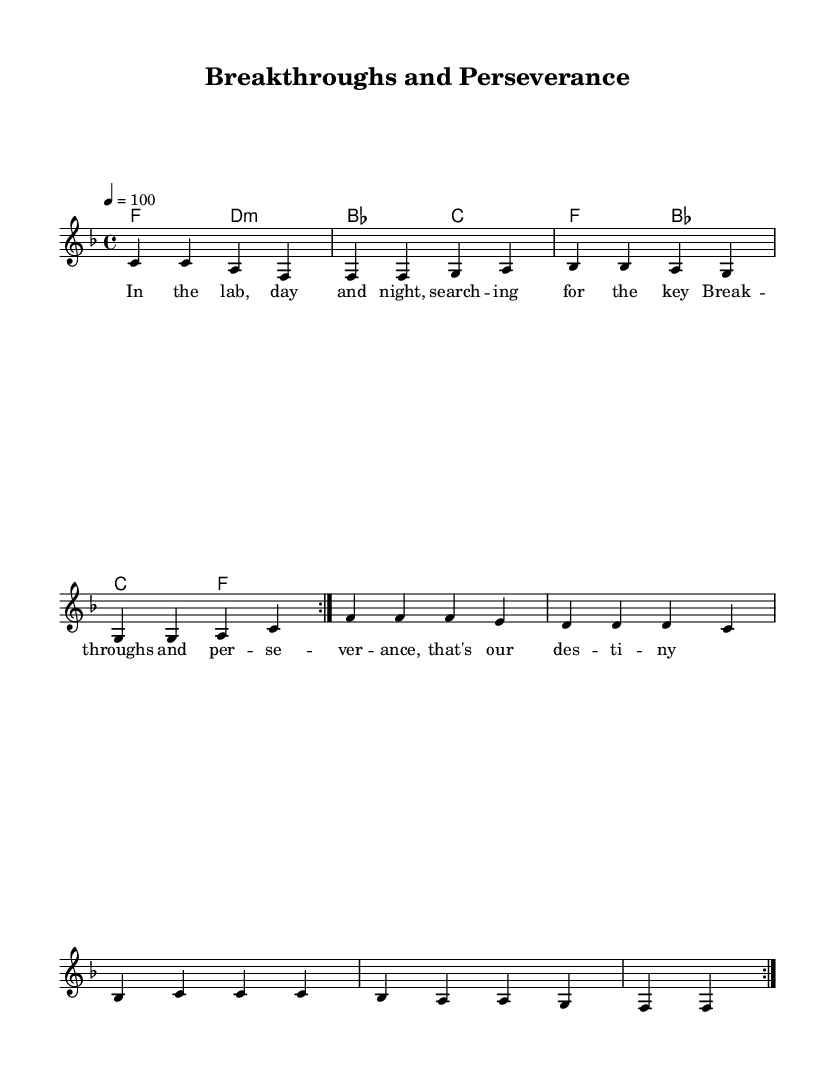What is the key signature of this music? The key signature is F major, which consists of one flat (B flat). This can be determined by looking at the key signature at the beginning of the score, which shows the circle of fifths layout where F is the fourth position, indicating it has one flat.
Answer: F major What is the time signature of this music? The time signature is 4/4, which means there are four beats in each measure and the quarter note gets one beat. This is visible near the beginning of the score where the time signature is indicated.
Answer: 4/4 What is the tempo marking for this piece? The tempo is marked as 100 beats per minute, shown by the marking "4 = 100" at the beginning of the score. This indicates the speed at which the piece should be performed.
Answer: 100 How many measures are there in the melody section? There are eight measures in the melody section. This can be confirmed by counting the number of bar lines in the melody section provided in the code.
Answer: 8 How many times is the melody repeated? The melody is repeated twice, as indicated by the "repeat volta 2" directive at the beginning of the melody line in the score. This shows that the section within the repeat should be played two times.
Answer: 2 What kind of lyrics are present in this piece? The lyrics are themed around scientific breakthroughs and perseverance, reflecting a journey in a lab. This can be inferred by analyzing the content of the lyric lines in the score that express dedication and striving for success.
Answer: Scientific breakthroughs 